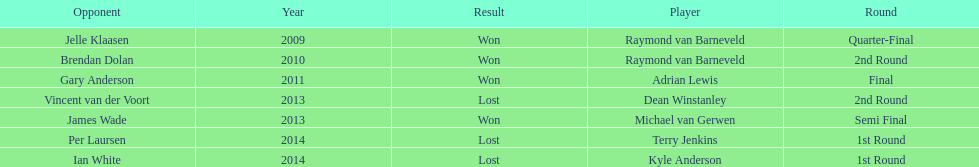Write the full table. {'header': ['Opponent', 'Year', 'Result', 'Player', 'Round'], 'rows': [['Jelle Klaasen', '2009', 'Won', 'Raymond van Barneveld', 'Quarter-Final'], ['Brendan Dolan', '2010', 'Won', 'Raymond van Barneveld', '2nd Round'], ['Gary Anderson', '2011', 'Won', 'Adrian Lewis', 'Final'], ['Vincent van der Voort', '2013', 'Lost', 'Dean Winstanley', '2nd Round'], ['James Wade', '2013', 'Won', 'Michael van Gerwen', 'Semi Final'], ['Per Laursen', '2014', 'Lost', 'Terry Jenkins', '1st Round'], ['Ian White', '2014', 'Lost', 'Kyle Anderson', '1st Round']]} Who was the last to win against his opponent? Michael van Gerwen. 